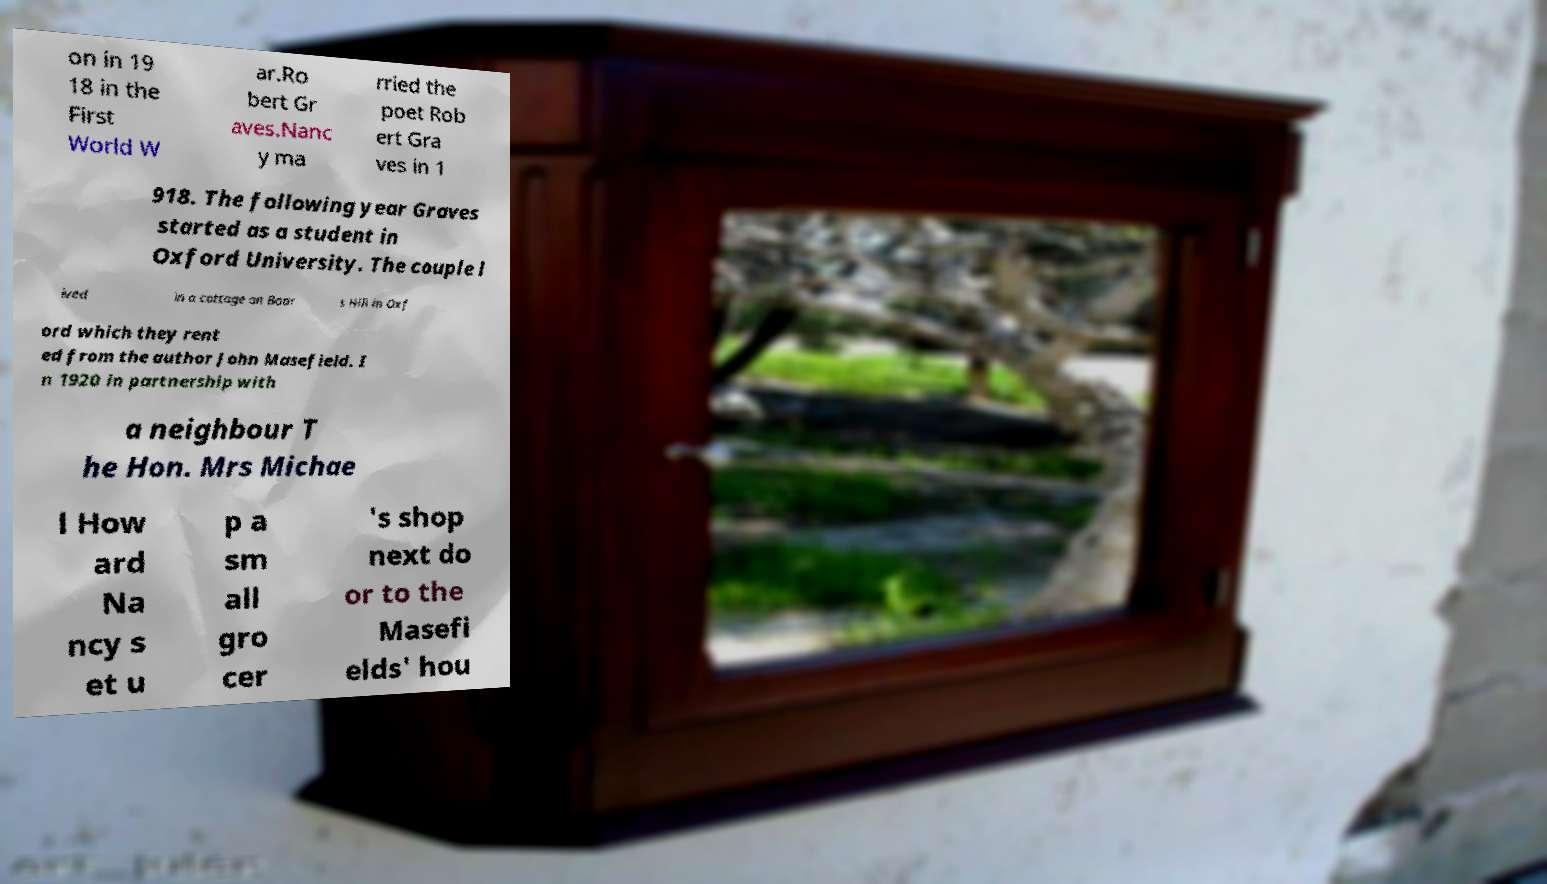Please read and relay the text visible in this image. What does it say? on in 19 18 in the First World W ar.Ro bert Gr aves.Nanc y ma rried the poet Rob ert Gra ves in 1 918. The following year Graves started as a student in Oxford University. The couple l ived in a cottage on Boar s Hill in Oxf ord which they rent ed from the author John Masefield. I n 1920 in partnership with a neighbour T he Hon. Mrs Michae l How ard Na ncy s et u p a sm all gro cer 's shop next do or to the Masefi elds' hou 